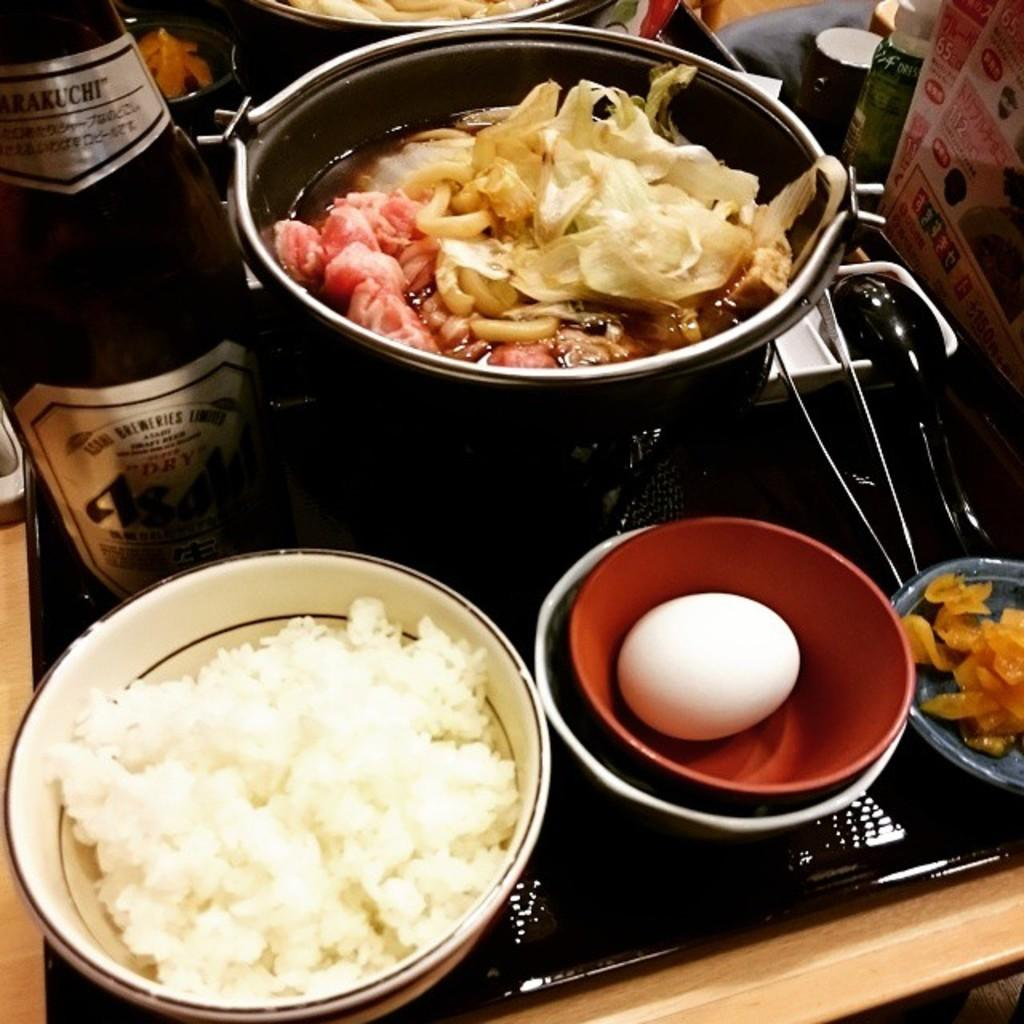<image>
Provide a brief description of the given image. The number 65 is visible on a poster near where an asian meal is being cooked. 